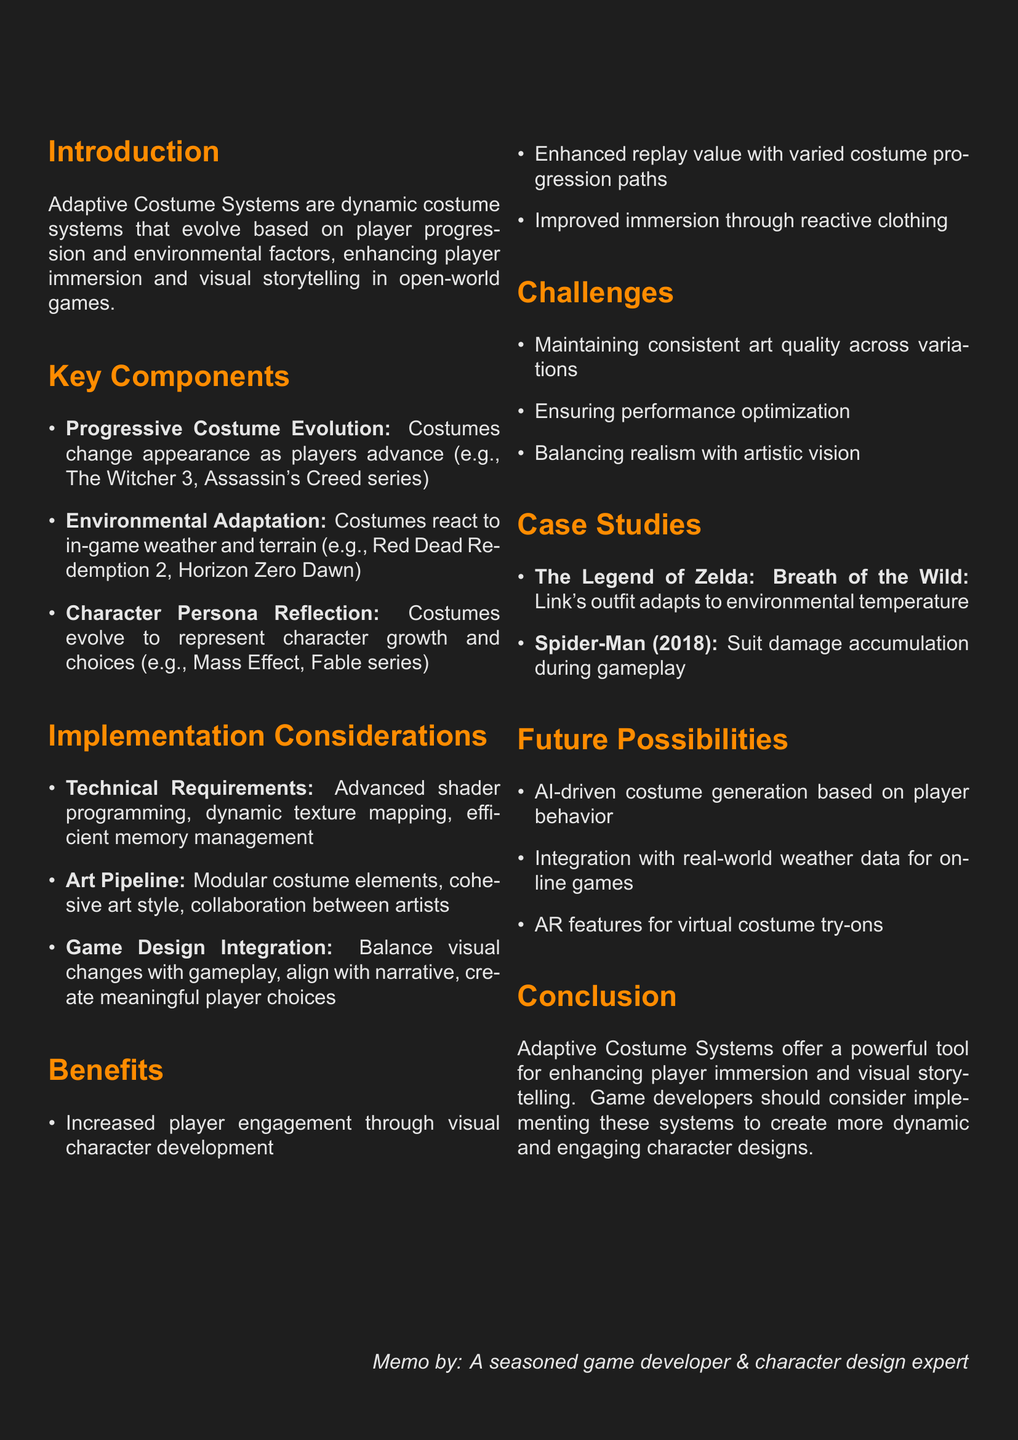What is the main concept of the memo? The main concept outlined in the memo is the Adaptive Costume Systems, which are dynamic costume systems for open-world games.
Answer: Adaptive Costume Systems What enhances player immersion according to the memo? The memo states that Adaptive Costume Systems enhance player immersion and visual storytelling.
Answer: Visual storytelling Which game is cited as an example of Progressive Costume Evolution? An example of Progressive Costume Evolution mentioned in the memo is The Witcher 3.
Answer: The Witcher 3 What challenge is highlighted regarding costume variations? The memo discusses the challenge of maintaining consistent art quality across all costume variations.
Answer: Consistent art quality What are AI-driven costume generations based on? The memo suggests that future possibilities include AI-driven costume generation based on player behavior.
Answer: Player behavior How many key components are listed in the document? The document lists three key components of Adaptive Costume Systems.
Answer: Three What is one benefit of implementing Adaptive Costume Systems? One benefit mentioned is increased player engagement through visual character development.
Answer: Increased player engagement What future possibility involves augmented reality? The memo mentions augmented reality features allowing players to virtually try on game costumes.
Answer: Virtual try on Which game demonstrates environmental adaptation in costumes? The memo documents Red Dead Redemption 2 as a game that illustrates environmental adaptation in costumes.
Answer: Red Dead Redemption 2 